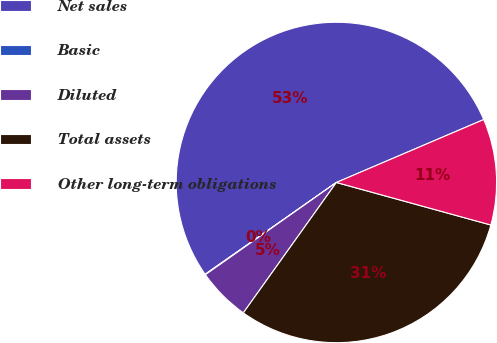Convert chart. <chart><loc_0><loc_0><loc_500><loc_500><pie_chart><fcel>Net sales<fcel>Basic<fcel>Diluted<fcel>Total assets<fcel>Other long-term obligations<nl><fcel>53.29%<fcel>0.05%<fcel>5.37%<fcel>30.59%<fcel>10.7%<nl></chart> 